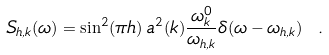<formula> <loc_0><loc_0><loc_500><loc_500>S _ { h , k } ( \omega ) = \sin ^ { 2 } ( \pi h ) \, a ^ { 2 } ( k ) \frac { \omega ^ { 0 } _ { k } } { \omega _ { h , k } } \delta ( \omega - \omega _ { h , k } ) \ .</formula> 